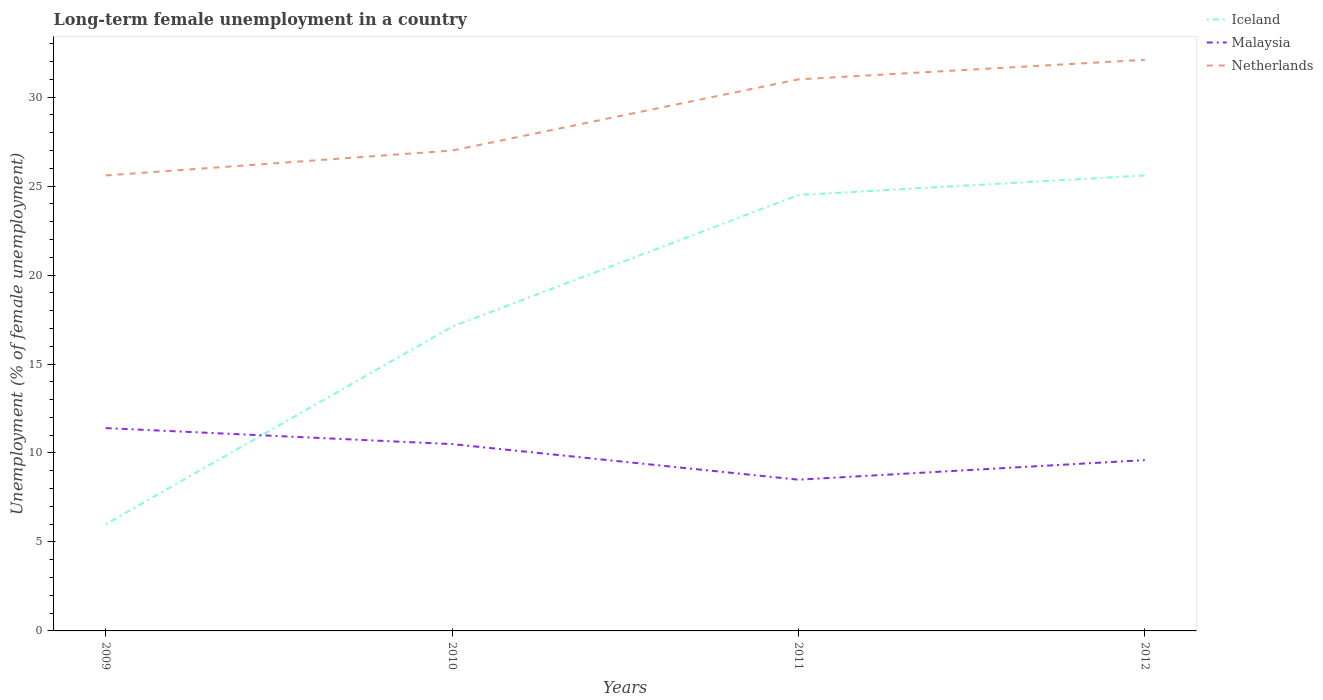How many different coloured lines are there?
Your response must be concise. 3. In which year was the percentage of long-term unemployed female population in Netherlands maximum?
Give a very brief answer. 2009. What is the total percentage of long-term unemployed female population in Malaysia in the graph?
Ensure brevity in your answer.  2.9. What is the difference between the highest and the second highest percentage of long-term unemployed female population in Iceland?
Offer a terse response. 19.6. How many years are there in the graph?
Offer a very short reply. 4. What is the difference between two consecutive major ticks on the Y-axis?
Offer a very short reply. 5. Are the values on the major ticks of Y-axis written in scientific E-notation?
Give a very brief answer. No. Does the graph contain grids?
Offer a very short reply. No. How are the legend labels stacked?
Give a very brief answer. Vertical. What is the title of the graph?
Ensure brevity in your answer.  Long-term female unemployment in a country. Does "Lao PDR" appear as one of the legend labels in the graph?
Make the answer very short. No. What is the label or title of the Y-axis?
Ensure brevity in your answer.  Unemployment (% of female unemployment). What is the Unemployment (% of female unemployment) of Malaysia in 2009?
Ensure brevity in your answer.  11.4. What is the Unemployment (% of female unemployment) in Netherlands in 2009?
Offer a terse response. 25.6. What is the Unemployment (% of female unemployment) of Iceland in 2010?
Keep it short and to the point. 17.1. What is the Unemployment (% of female unemployment) of Malaysia in 2010?
Ensure brevity in your answer.  10.5. What is the Unemployment (% of female unemployment) of Netherlands in 2010?
Offer a very short reply. 27. What is the Unemployment (% of female unemployment) of Iceland in 2011?
Keep it short and to the point. 24.5. What is the Unemployment (% of female unemployment) in Iceland in 2012?
Your response must be concise. 25.6. What is the Unemployment (% of female unemployment) of Malaysia in 2012?
Provide a succinct answer. 9.6. What is the Unemployment (% of female unemployment) of Netherlands in 2012?
Provide a succinct answer. 32.1. Across all years, what is the maximum Unemployment (% of female unemployment) in Iceland?
Offer a terse response. 25.6. Across all years, what is the maximum Unemployment (% of female unemployment) of Malaysia?
Give a very brief answer. 11.4. Across all years, what is the maximum Unemployment (% of female unemployment) in Netherlands?
Offer a very short reply. 32.1. Across all years, what is the minimum Unemployment (% of female unemployment) of Netherlands?
Your response must be concise. 25.6. What is the total Unemployment (% of female unemployment) of Iceland in the graph?
Your answer should be very brief. 73.2. What is the total Unemployment (% of female unemployment) of Malaysia in the graph?
Ensure brevity in your answer.  40. What is the total Unemployment (% of female unemployment) of Netherlands in the graph?
Keep it short and to the point. 115.7. What is the difference between the Unemployment (% of female unemployment) in Iceland in 2009 and that in 2010?
Provide a succinct answer. -11.1. What is the difference between the Unemployment (% of female unemployment) in Malaysia in 2009 and that in 2010?
Give a very brief answer. 0.9. What is the difference between the Unemployment (% of female unemployment) in Iceland in 2009 and that in 2011?
Offer a terse response. -18.5. What is the difference between the Unemployment (% of female unemployment) in Iceland in 2009 and that in 2012?
Ensure brevity in your answer.  -19.6. What is the difference between the Unemployment (% of female unemployment) in Netherlands in 2009 and that in 2012?
Offer a very short reply. -6.5. What is the difference between the Unemployment (% of female unemployment) in Iceland in 2010 and that in 2012?
Give a very brief answer. -8.5. What is the difference between the Unemployment (% of female unemployment) in Malaysia in 2010 and that in 2012?
Keep it short and to the point. 0.9. What is the difference between the Unemployment (% of female unemployment) in Netherlands in 2010 and that in 2012?
Offer a very short reply. -5.1. What is the difference between the Unemployment (% of female unemployment) of Iceland in 2011 and that in 2012?
Ensure brevity in your answer.  -1.1. What is the difference between the Unemployment (% of female unemployment) in Malaysia in 2011 and that in 2012?
Your response must be concise. -1.1. What is the difference between the Unemployment (% of female unemployment) in Iceland in 2009 and the Unemployment (% of female unemployment) in Netherlands in 2010?
Provide a succinct answer. -21. What is the difference between the Unemployment (% of female unemployment) of Malaysia in 2009 and the Unemployment (% of female unemployment) of Netherlands in 2010?
Keep it short and to the point. -15.6. What is the difference between the Unemployment (% of female unemployment) of Iceland in 2009 and the Unemployment (% of female unemployment) of Malaysia in 2011?
Ensure brevity in your answer.  -2.5. What is the difference between the Unemployment (% of female unemployment) of Malaysia in 2009 and the Unemployment (% of female unemployment) of Netherlands in 2011?
Make the answer very short. -19.6. What is the difference between the Unemployment (% of female unemployment) of Iceland in 2009 and the Unemployment (% of female unemployment) of Netherlands in 2012?
Keep it short and to the point. -26.1. What is the difference between the Unemployment (% of female unemployment) of Malaysia in 2009 and the Unemployment (% of female unemployment) of Netherlands in 2012?
Your answer should be compact. -20.7. What is the difference between the Unemployment (% of female unemployment) of Malaysia in 2010 and the Unemployment (% of female unemployment) of Netherlands in 2011?
Make the answer very short. -20.5. What is the difference between the Unemployment (% of female unemployment) in Malaysia in 2010 and the Unemployment (% of female unemployment) in Netherlands in 2012?
Provide a short and direct response. -21.6. What is the difference between the Unemployment (% of female unemployment) in Malaysia in 2011 and the Unemployment (% of female unemployment) in Netherlands in 2012?
Provide a succinct answer. -23.6. What is the average Unemployment (% of female unemployment) in Netherlands per year?
Provide a short and direct response. 28.93. In the year 2009, what is the difference between the Unemployment (% of female unemployment) in Iceland and Unemployment (% of female unemployment) in Malaysia?
Offer a terse response. -5.4. In the year 2009, what is the difference between the Unemployment (% of female unemployment) of Iceland and Unemployment (% of female unemployment) of Netherlands?
Offer a very short reply. -19.6. In the year 2009, what is the difference between the Unemployment (% of female unemployment) in Malaysia and Unemployment (% of female unemployment) in Netherlands?
Make the answer very short. -14.2. In the year 2010, what is the difference between the Unemployment (% of female unemployment) in Iceland and Unemployment (% of female unemployment) in Malaysia?
Keep it short and to the point. 6.6. In the year 2010, what is the difference between the Unemployment (% of female unemployment) in Malaysia and Unemployment (% of female unemployment) in Netherlands?
Provide a short and direct response. -16.5. In the year 2011, what is the difference between the Unemployment (% of female unemployment) of Iceland and Unemployment (% of female unemployment) of Malaysia?
Provide a succinct answer. 16. In the year 2011, what is the difference between the Unemployment (% of female unemployment) in Malaysia and Unemployment (% of female unemployment) in Netherlands?
Offer a terse response. -22.5. In the year 2012, what is the difference between the Unemployment (% of female unemployment) of Malaysia and Unemployment (% of female unemployment) of Netherlands?
Offer a terse response. -22.5. What is the ratio of the Unemployment (% of female unemployment) of Iceland in 2009 to that in 2010?
Provide a short and direct response. 0.35. What is the ratio of the Unemployment (% of female unemployment) of Malaysia in 2009 to that in 2010?
Give a very brief answer. 1.09. What is the ratio of the Unemployment (% of female unemployment) of Netherlands in 2009 to that in 2010?
Provide a short and direct response. 0.95. What is the ratio of the Unemployment (% of female unemployment) in Iceland in 2009 to that in 2011?
Provide a short and direct response. 0.24. What is the ratio of the Unemployment (% of female unemployment) of Malaysia in 2009 to that in 2011?
Give a very brief answer. 1.34. What is the ratio of the Unemployment (% of female unemployment) of Netherlands in 2009 to that in 2011?
Offer a very short reply. 0.83. What is the ratio of the Unemployment (% of female unemployment) of Iceland in 2009 to that in 2012?
Offer a very short reply. 0.23. What is the ratio of the Unemployment (% of female unemployment) in Malaysia in 2009 to that in 2012?
Offer a terse response. 1.19. What is the ratio of the Unemployment (% of female unemployment) of Netherlands in 2009 to that in 2012?
Give a very brief answer. 0.8. What is the ratio of the Unemployment (% of female unemployment) of Iceland in 2010 to that in 2011?
Your answer should be very brief. 0.7. What is the ratio of the Unemployment (% of female unemployment) in Malaysia in 2010 to that in 2011?
Your answer should be compact. 1.24. What is the ratio of the Unemployment (% of female unemployment) in Netherlands in 2010 to that in 2011?
Your answer should be very brief. 0.87. What is the ratio of the Unemployment (% of female unemployment) in Iceland in 2010 to that in 2012?
Offer a very short reply. 0.67. What is the ratio of the Unemployment (% of female unemployment) of Malaysia in 2010 to that in 2012?
Offer a terse response. 1.09. What is the ratio of the Unemployment (% of female unemployment) in Netherlands in 2010 to that in 2012?
Provide a short and direct response. 0.84. What is the ratio of the Unemployment (% of female unemployment) in Malaysia in 2011 to that in 2012?
Provide a short and direct response. 0.89. What is the ratio of the Unemployment (% of female unemployment) in Netherlands in 2011 to that in 2012?
Your response must be concise. 0.97. What is the difference between the highest and the second highest Unemployment (% of female unemployment) in Malaysia?
Your answer should be very brief. 0.9. What is the difference between the highest and the lowest Unemployment (% of female unemployment) of Iceland?
Provide a succinct answer. 19.6. What is the difference between the highest and the lowest Unemployment (% of female unemployment) in Netherlands?
Offer a very short reply. 6.5. 